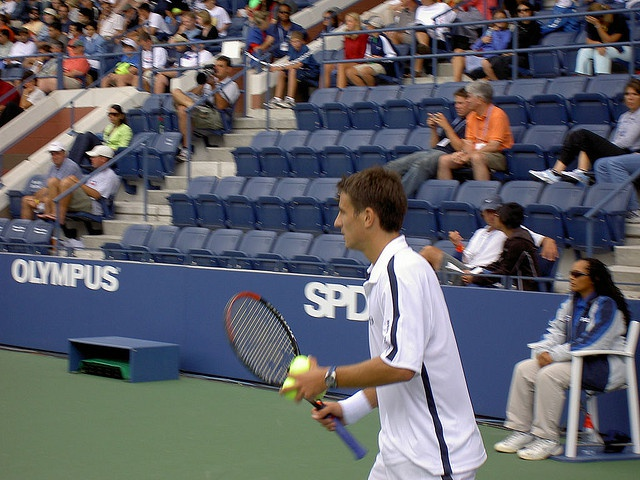Describe the objects in this image and their specific colors. I can see people in black, gray, navy, and darkgray tones, chair in black, navy, and gray tones, people in black, lavender, and darkgray tones, people in black, darkgray, gray, and navy tones, and chair in black, navy, darkgray, and gray tones in this image. 